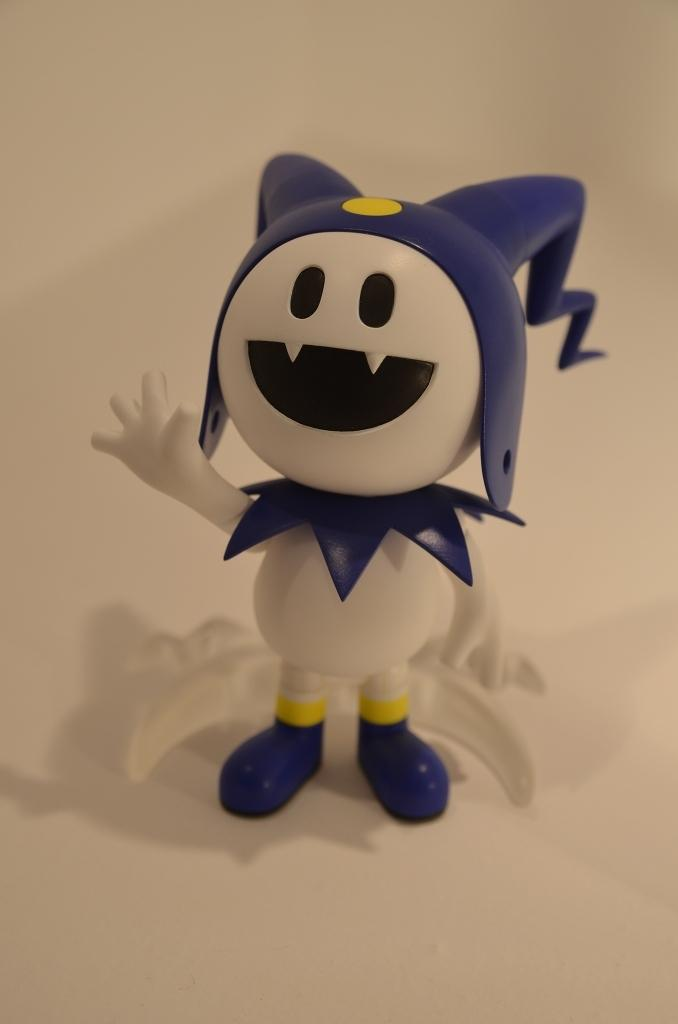What is the main object in the image? There is a toy in the image. Can you describe the colors of the toy? The toy has white, blue, black, and yellow colors. What is the background of the toy in the image? The toy is on a white floor. What month is it in the image? The month is not mentioned or depicted in the image, so it cannot be determined. 